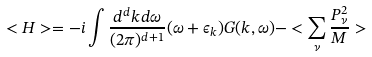Convert formula to latex. <formula><loc_0><loc_0><loc_500><loc_500>< H > = - i \int \frac { d ^ { d } k d \omega } { ( 2 \pi ) ^ { d + 1 } } ( \omega + \epsilon _ { k } ) G ( k , \omega ) - < \sum _ { \nu } \frac { P ^ { 2 } _ { \nu } } { M } ></formula> 